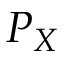Convert formula to latex. <formula><loc_0><loc_0><loc_500><loc_500>P _ { X }</formula> 